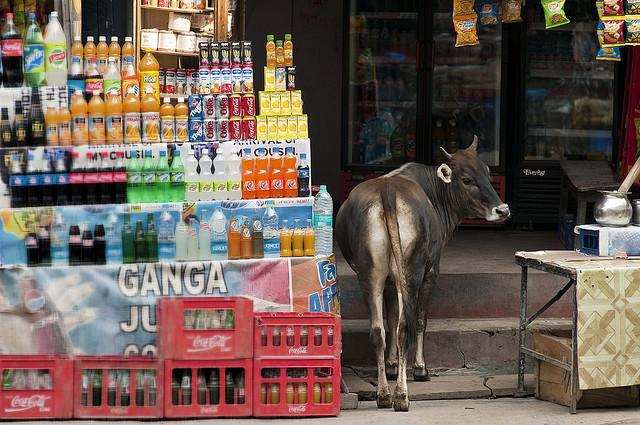The first five letters in white that are on the sign are used in spelling what style?

Choices:
A) bohemian
B) gangnam
C) grunge
D) tiger gangnam 